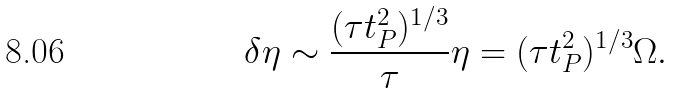Convert formula to latex. <formula><loc_0><loc_0><loc_500><loc_500>\delta \eta \sim \frac { ( \tau t _ { P } ^ { 2 } ) ^ { 1 / 3 } } { \tau } \eta = ( \tau t _ { P } ^ { 2 } ) ^ { 1 / 3 } \Omega .</formula> 